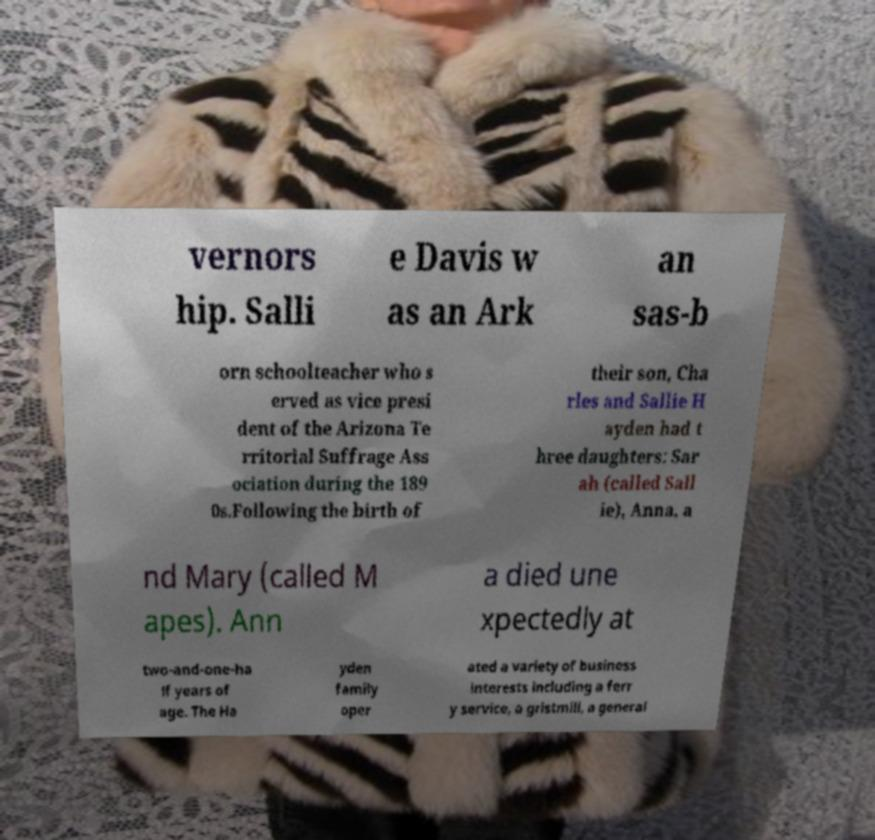Could you assist in decoding the text presented in this image and type it out clearly? vernors hip. Salli e Davis w as an Ark an sas-b orn schoolteacher who s erved as vice presi dent of the Arizona Te rritorial Suffrage Ass ociation during the 189 0s.Following the birth of their son, Cha rles and Sallie H ayden had t hree daughters: Sar ah (called Sall ie), Anna, a nd Mary (called M apes). Ann a died une xpectedly at two-and-one-ha lf years of age. The Ha yden family oper ated a variety of business interests including a ferr y service, a gristmill, a general 